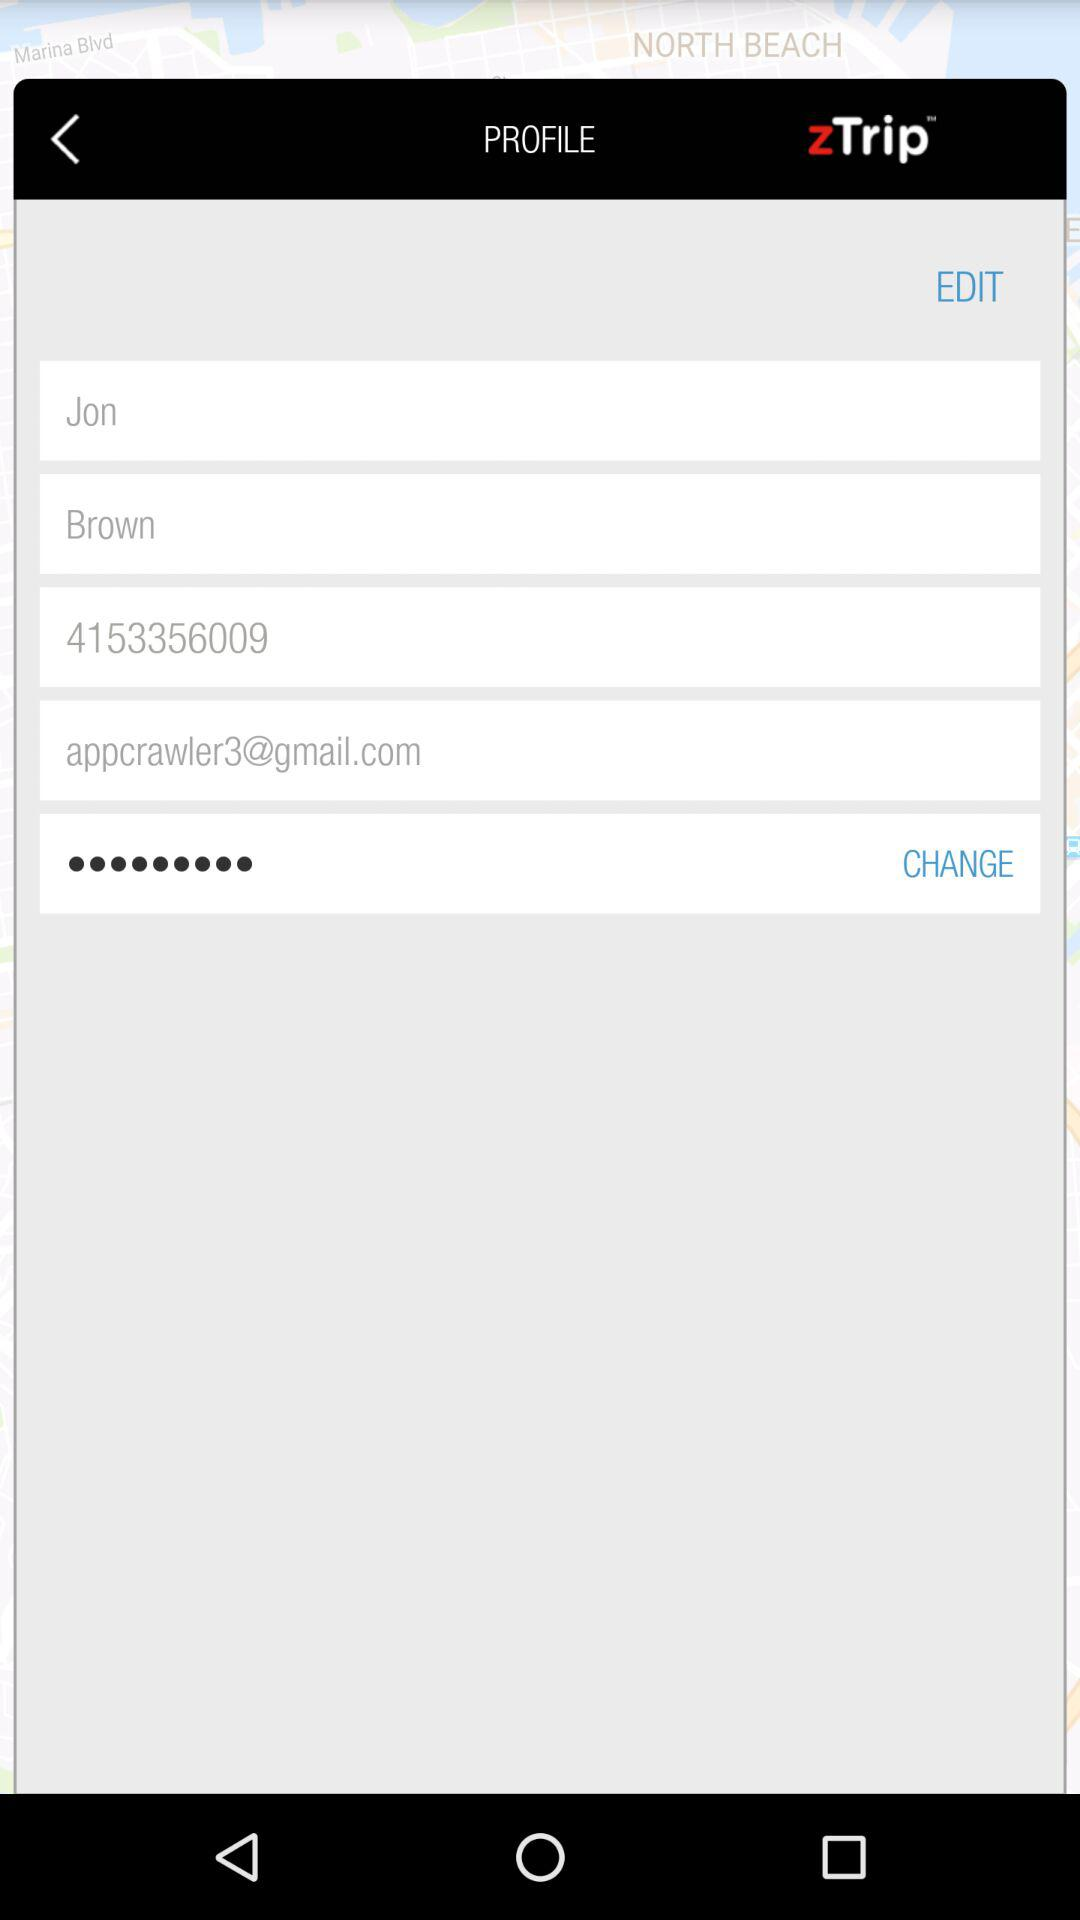What is the phone number? The phone number is 4153356009. 